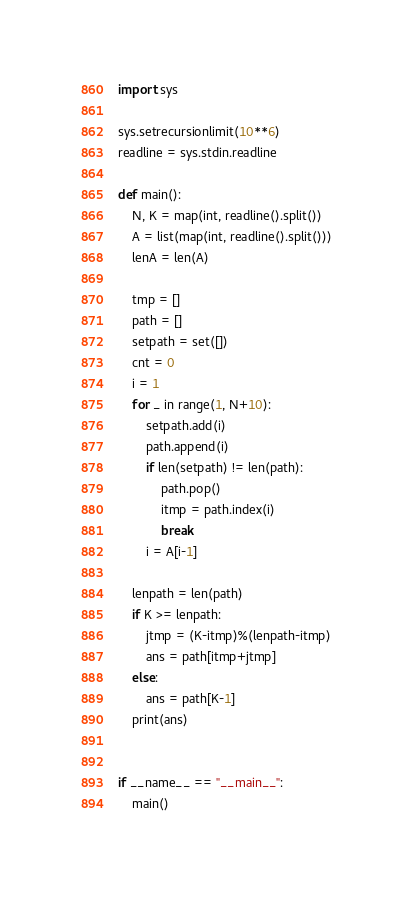<code> <loc_0><loc_0><loc_500><loc_500><_Python_>import sys

sys.setrecursionlimit(10**6)
readline = sys.stdin.readline

def main():
    N, K = map(int, readline().split())
    A = list(map(int, readline().split()))
    lenA = len(A)

    tmp = []
    path = []
    setpath = set([])
    cnt = 0
    i = 1
    for _ in range(1, N+10):
        setpath.add(i)
        path.append(i)
        if len(setpath) != len(path):
            path.pop()
            itmp = path.index(i)
            break
        i = A[i-1]

    lenpath = len(path)
    if K >= lenpath:
        jtmp = (K-itmp)%(lenpath-itmp)
        ans = path[itmp+jtmp]
    else:
        ans = path[K-1]
    print(ans)


if __name__ == "__main__":
    main()
</code> 